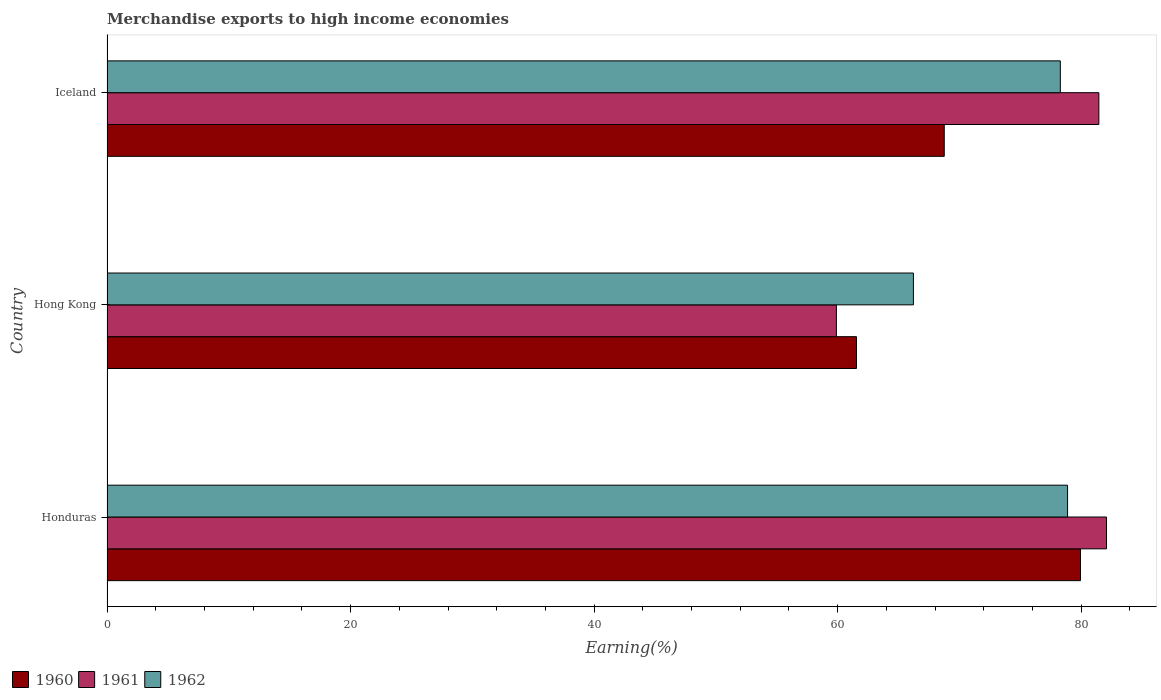How many different coloured bars are there?
Make the answer very short. 3. How many groups of bars are there?
Provide a short and direct response. 3. Are the number of bars per tick equal to the number of legend labels?
Your answer should be compact. Yes. How many bars are there on the 1st tick from the bottom?
Offer a very short reply. 3. What is the label of the 1st group of bars from the top?
Give a very brief answer. Iceland. In how many cases, is the number of bars for a given country not equal to the number of legend labels?
Provide a succinct answer. 0. What is the percentage of amount earned from merchandise exports in 1960 in Iceland?
Offer a terse response. 68.75. Across all countries, what is the maximum percentage of amount earned from merchandise exports in 1961?
Offer a terse response. 82.07. Across all countries, what is the minimum percentage of amount earned from merchandise exports in 1960?
Keep it short and to the point. 61.54. In which country was the percentage of amount earned from merchandise exports in 1961 maximum?
Your answer should be compact. Honduras. In which country was the percentage of amount earned from merchandise exports in 1962 minimum?
Offer a very short reply. Hong Kong. What is the total percentage of amount earned from merchandise exports in 1960 in the graph?
Offer a very short reply. 210.23. What is the difference between the percentage of amount earned from merchandise exports in 1962 in Honduras and that in Iceland?
Ensure brevity in your answer.  0.59. What is the difference between the percentage of amount earned from merchandise exports in 1962 in Honduras and the percentage of amount earned from merchandise exports in 1960 in Iceland?
Provide a short and direct response. 10.12. What is the average percentage of amount earned from merchandise exports in 1961 per country?
Provide a short and direct response. 74.47. What is the difference between the percentage of amount earned from merchandise exports in 1961 and percentage of amount earned from merchandise exports in 1962 in Iceland?
Ensure brevity in your answer.  3.16. In how many countries, is the percentage of amount earned from merchandise exports in 1962 greater than 12 %?
Provide a succinct answer. 3. What is the ratio of the percentage of amount earned from merchandise exports in 1960 in Honduras to that in Iceland?
Offer a terse response. 1.16. Is the percentage of amount earned from merchandise exports in 1961 in Hong Kong less than that in Iceland?
Offer a very short reply. Yes. Is the difference between the percentage of amount earned from merchandise exports in 1961 in Honduras and Hong Kong greater than the difference between the percentage of amount earned from merchandise exports in 1962 in Honduras and Hong Kong?
Your answer should be very brief. Yes. What is the difference between the highest and the second highest percentage of amount earned from merchandise exports in 1961?
Keep it short and to the point. 0.63. What is the difference between the highest and the lowest percentage of amount earned from merchandise exports in 1961?
Your answer should be compact. 22.18. Is the sum of the percentage of amount earned from merchandise exports in 1962 in Hong Kong and Iceland greater than the maximum percentage of amount earned from merchandise exports in 1961 across all countries?
Provide a short and direct response. Yes. What does the 1st bar from the top in Hong Kong represents?
Keep it short and to the point. 1962. What does the 2nd bar from the bottom in Hong Kong represents?
Make the answer very short. 1961. How many bars are there?
Provide a succinct answer. 9. Are all the bars in the graph horizontal?
Provide a short and direct response. Yes. What is the difference between two consecutive major ticks on the X-axis?
Make the answer very short. 20. Are the values on the major ticks of X-axis written in scientific E-notation?
Make the answer very short. No. Does the graph contain any zero values?
Make the answer very short. No. Does the graph contain grids?
Ensure brevity in your answer.  No. Where does the legend appear in the graph?
Make the answer very short. Bottom left. How many legend labels are there?
Provide a succinct answer. 3. What is the title of the graph?
Your answer should be very brief. Merchandise exports to high income economies. Does "2003" appear as one of the legend labels in the graph?
Your answer should be compact. No. What is the label or title of the X-axis?
Make the answer very short. Earning(%). What is the label or title of the Y-axis?
Your response must be concise. Country. What is the Earning(%) of 1960 in Honduras?
Your answer should be very brief. 79.94. What is the Earning(%) in 1961 in Honduras?
Give a very brief answer. 82.07. What is the Earning(%) in 1962 in Honduras?
Offer a very short reply. 78.88. What is the Earning(%) of 1960 in Hong Kong?
Offer a terse response. 61.54. What is the Earning(%) in 1961 in Hong Kong?
Your response must be concise. 59.89. What is the Earning(%) in 1962 in Hong Kong?
Your answer should be compact. 66.22. What is the Earning(%) of 1960 in Iceland?
Offer a terse response. 68.75. What is the Earning(%) of 1961 in Iceland?
Your answer should be compact. 81.44. What is the Earning(%) in 1962 in Iceland?
Offer a very short reply. 78.28. Across all countries, what is the maximum Earning(%) of 1960?
Provide a succinct answer. 79.94. Across all countries, what is the maximum Earning(%) of 1961?
Make the answer very short. 82.07. Across all countries, what is the maximum Earning(%) in 1962?
Provide a succinct answer. 78.88. Across all countries, what is the minimum Earning(%) of 1960?
Keep it short and to the point. 61.54. Across all countries, what is the minimum Earning(%) of 1961?
Offer a terse response. 59.89. Across all countries, what is the minimum Earning(%) of 1962?
Offer a very short reply. 66.22. What is the total Earning(%) in 1960 in the graph?
Your response must be concise. 210.23. What is the total Earning(%) of 1961 in the graph?
Make the answer very short. 223.41. What is the total Earning(%) in 1962 in the graph?
Offer a terse response. 223.37. What is the difference between the Earning(%) of 1960 in Honduras and that in Hong Kong?
Your answer should be compact. 18.39. What is the difference between the Earning(%) in 1961 in Honduras and that in Hong Kong?
Ensure brevity in your answer.  22.18. What is the difference between the Earning(%) of 1962 in Honduras and that in Hong Kong?
Keep it short and to the point. 12.66. What is the difference between the Earning(%) of 1960 in Honduras and that in Iceland?
Your response must be concise. 11.19. What is the difference between the Earning(%) in 1961 in Honduras and that in Iceland?
Ensure brevity in your answer.  0.63. What is the difference between the Earning(%) of 1962 in Honduras and that in Iceland?
Ensure brevity in your answer.  0.59. What is the difference between the Earning(%) in 1960 in Hong Kong and that in Iceland?
Give a very brief answer. -7.21. What is the difference between the Earning(%) of 1961 in Hong Kong and that in Iceland?
Keep it short and to the point. -21.55. What is the difference between the Earning(%) in 1962 in Hong Kong and that in Iceland?
Give a very brief answer. -12.07. What is the difference between the Earning(%) in 1960 in Honduras and the Earning(%) in 1961 in Hong Kong?
Your response must be concise. 20.05. What is the difference between the Earning(%) in 1960 in Honduras and the Earning(%) in 1962 in Hong Kong?
Offer a very short reply. 13.72. What is the difference between the Earning(%) in 1961 in Honduras and the Earning(%) in 1962 in Hong Kong?
Provide a succinct answer. 15.86. What is the difference between the Earning(%) of 1960 in Honduras and the Earning(%) of 1961 in Iceland?
Keep it short and to the point. -1.51. What is the difference between the Earning(%) of 1960 in Honduras and the Earning(%) of 1962 in Iceland?
Provide a short and direct response. 1.66. What is the difference between the Earning(%) of 1961 in Honduras and the Earning(%) of 1962 in Iceland?
Make the answer very short. 3.79. What is the difference between the Earning(%) in 1960 in Hong Kong and the Earning(%) in 1961 in Iceland?
Give a very brief answer. -19.9. What is the difference between the Earning(%) of 1960 in Hong Kong and the Earning(%) of 1962 in Iceland?
Your answer should be compact. -16.74. What is the difference between the Earning(%) of 1961 in Hong Kong and the Earning(%) of 1962 in Iceland?
Give a very brief answer. -18.39. What is the average Earning(%) of 1960 per country?
Provide a short and direct response. 70.08. What is the average Earning(%) of 1961 per country?
Ensure brevity in your answer.  74.47. What is the average Earning(%) in 1962 per country?
Keep it short and to the point. 74.46. What is the difference between the Earning(%) in 1960 and Earning(%) in 1961 in Honduras?
Provide a short and direct response. -2.14. What is the difference between the Earning(%) in 1960 and Earning(%) in 1962 in Honduras?
Your response must be concise. 1.06. What is the difference between the Earning(%) in 1961 and Earning(%) in 1962 in Honduras?
Keep it short and to the point. 3.2. What is the difference between the Earning(%) in 1960 and Earning(%) in 1961 in Hong Kong?
Offer a terse response. 1.65. What is the difference between the Earning(%) of 1960 and Earning(%) of 1962 in Hong Kong?
Your answer should be compact. -4.67. What is the difference between the Earning(%) of 1961 and Earning(%) of 1962 in Hong Kong?
Your response must be concise. -6.32. What is the difference between the Earning(%) in 1960 and Earning(%) in 1961 in Iceland?
Provide a succinct answer. -12.69. What is the difference between the Earning(%) in 1960 and Earning(%) in 1962 in Iceland?
Make the answer very short. -9.53. What is the difference between the Earning(%) of 1961 and Earning(%) of 1962 in Iceland?
Give a very brief answer. 3.16. What is the ratio of the Earning(%) in 1960 in Honduras to that in Hong Kong?
Give a very brief answer. 1.3. What is the ratio of the Earning(%) in 1961 in Honduras to that in Hong Kong?
Keep it short and to the point. 1.37. What is the ratio of the Earning(%) of 1962 in Honduras to that in Hong Kong?
Your answer should be very brief. 1.19. What is the ratio of the Earning(%) in 1960 in Honduras to that in Iceland?
Give a very brief answer. 1.16. What is the ratio of the Earning(%) in 1961 in Honduras to that in Iceland?
Offer a very short reply. 1.01. What is the ratio of the Earning(%) of 1962 in Honduras to that in Iceland?
Make the answer very short. 1.01. What is the ratio of the Earning(%) of 1960 in Hong Kong to that in Iceland?
Provide a short and direct response. 0.9. What is the ratio of the Earning(%) in 1961 in Hong Kong to that in Iceland?
Give a very brief answer. 0.74. What is the ratio of the Earning(%) in 1962 in Hong Kong to that in Iceland?
Your answer should be compact. 0.85. What is the difference between the highest and the second highest Earning(%) in 1960?
Your answer should be compact. 11.19. What is the difference between the highest and the second highest Earning(%) in 1961?
Make the answer very short. 0.63. What is the difference between the highest and the second highest Earning(%) in 1962?
Keep it short and to the point. 0.59. What is the difference between the highest and the lowest Earning(%) in 1960?
Offer a terse response. 18.39. What is the difference between the highest and the lowest Earning(%) of 1961?
Keep it short and to the point. 22.18. What is the difference between the highest and the lowest Earning(%) of 1962?
Offer a very short reply. 12.66. 